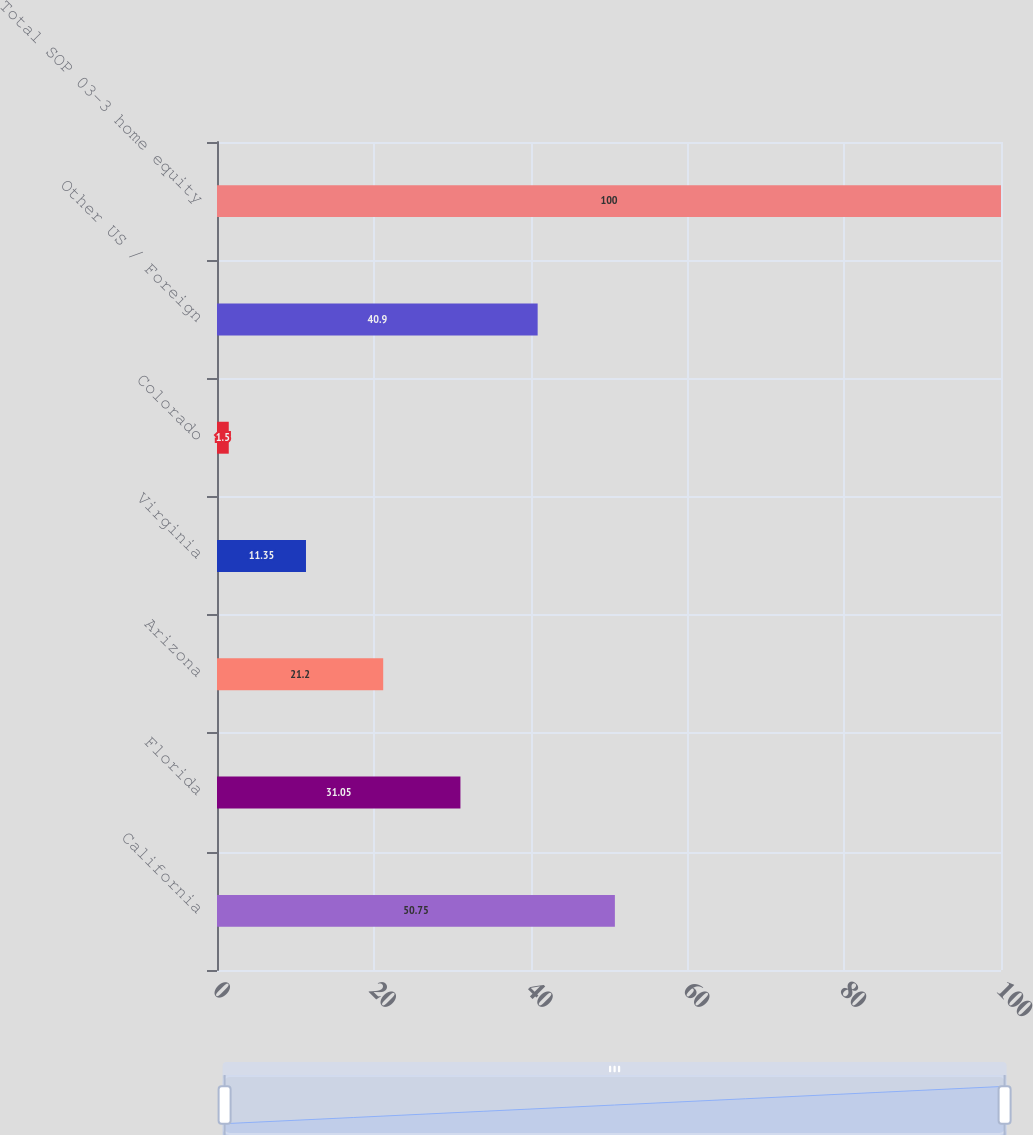Convert chart. <chart><loc_0><loc_0><loc_500><loc_500><bar_chart><fcel>California<fcel>Florida<fcel>Arizona<fcel>Virginia<fcel>Colorado<fcel>Other US / Foreign<fcel>Total SOP 03-3 home equity<nl><fcel>50.75<fcel>31.05<fcel>21.2<fcel>11.35<fcel>1.5<fcel>40.9<fcel>100<nl></chart> 